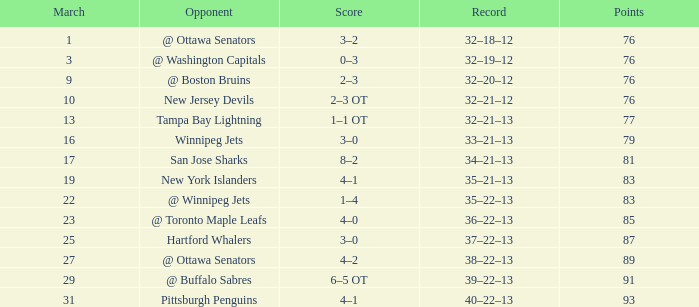In how many games is the march 19 and the points are under 83? 0.0. 